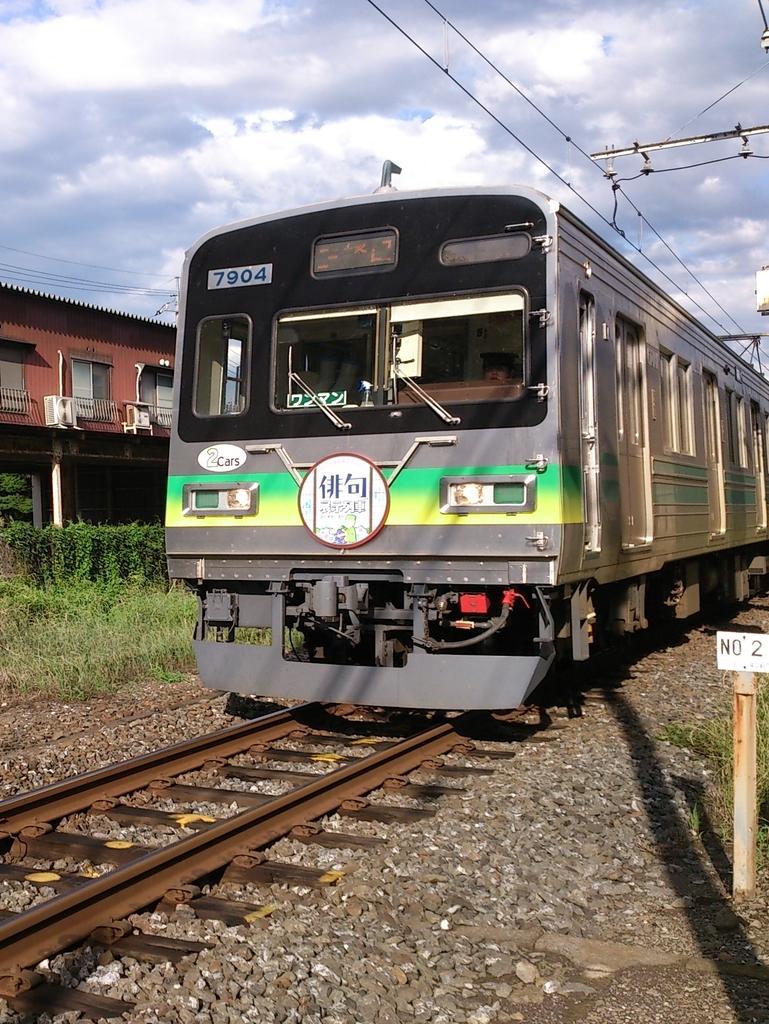Please provide a concise description of this image. In this picture I can see a train on the track, side I can see some rocks, plants, grass and also I can see shed. 